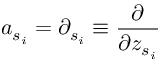<formula> <loc_0><loc_0><loc_500><loc_500>a _ { s _ { i } } = \partial _ { s _ { i } } \equiv \frac { \partial } { \partial z _ { s _ { i } } }</formula> 